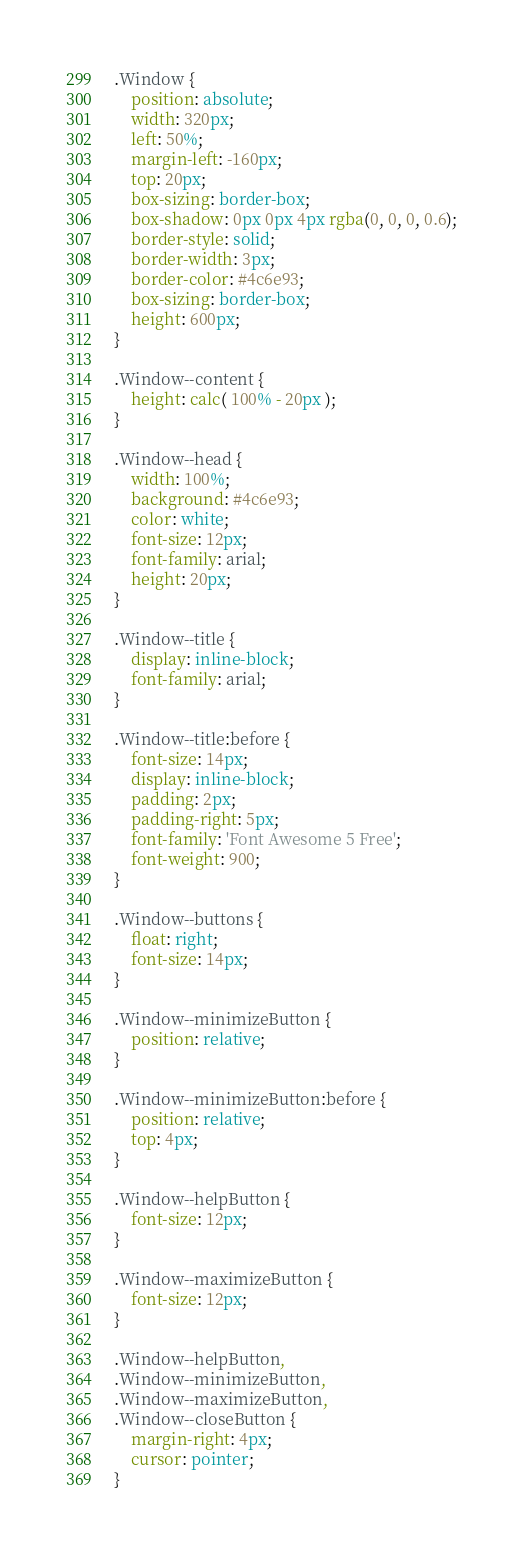<code> <loc_0><loc_0><loc_500><loc_500><_CSS_>
.Window {
    position: absolute;
    width: 320px;
    left: 50%;
    margin-left: -160px;
    top: 20px;
    box-sizing: border-box;
    box-shadow: 0px 0px 4px rgba(0, 0, 0, 0.6);
    border-style: solid;
    border-width: 3px;
    border-color: #4c6e93;
    box-sizing: border-box;
    height: 600px;
}

.Window--content {
	height: calc( 100% - 20px );
}

.Window--head {
    width: 100%;
    background: #4c6e93;
    color: white;
    font-size: 12px;
    font-family: arial;
    height: 20px;
}

.Window--title {
    display: inline-block;
    font-family: arial;
}

.Window--title:before {
    font-size: 14px;
    display: inline-block;
    padding: 2px;
    padding-right: 5px;
    font-family: 'Font Awesome 5 Free';
    font-weight: 900;
}

.Window--buttons {
    float: right;
    font-size: 14px;
}

.Window--minimizeButton {
    position: relative;
}

.Window--minimizeButton:before {
    position: relative;
    top: 4px;
}

.Window--helpButton {
    font-size: 12px;
}

.Window--maximizeButton {
    font-size: 12px;
}

.Window--helpButton,
.Window--minimizeButton,
.Window--maximizeButton,
.Window--closeButton {
    margin-right: 4px;
    cursor: pointer;
}
</code> 